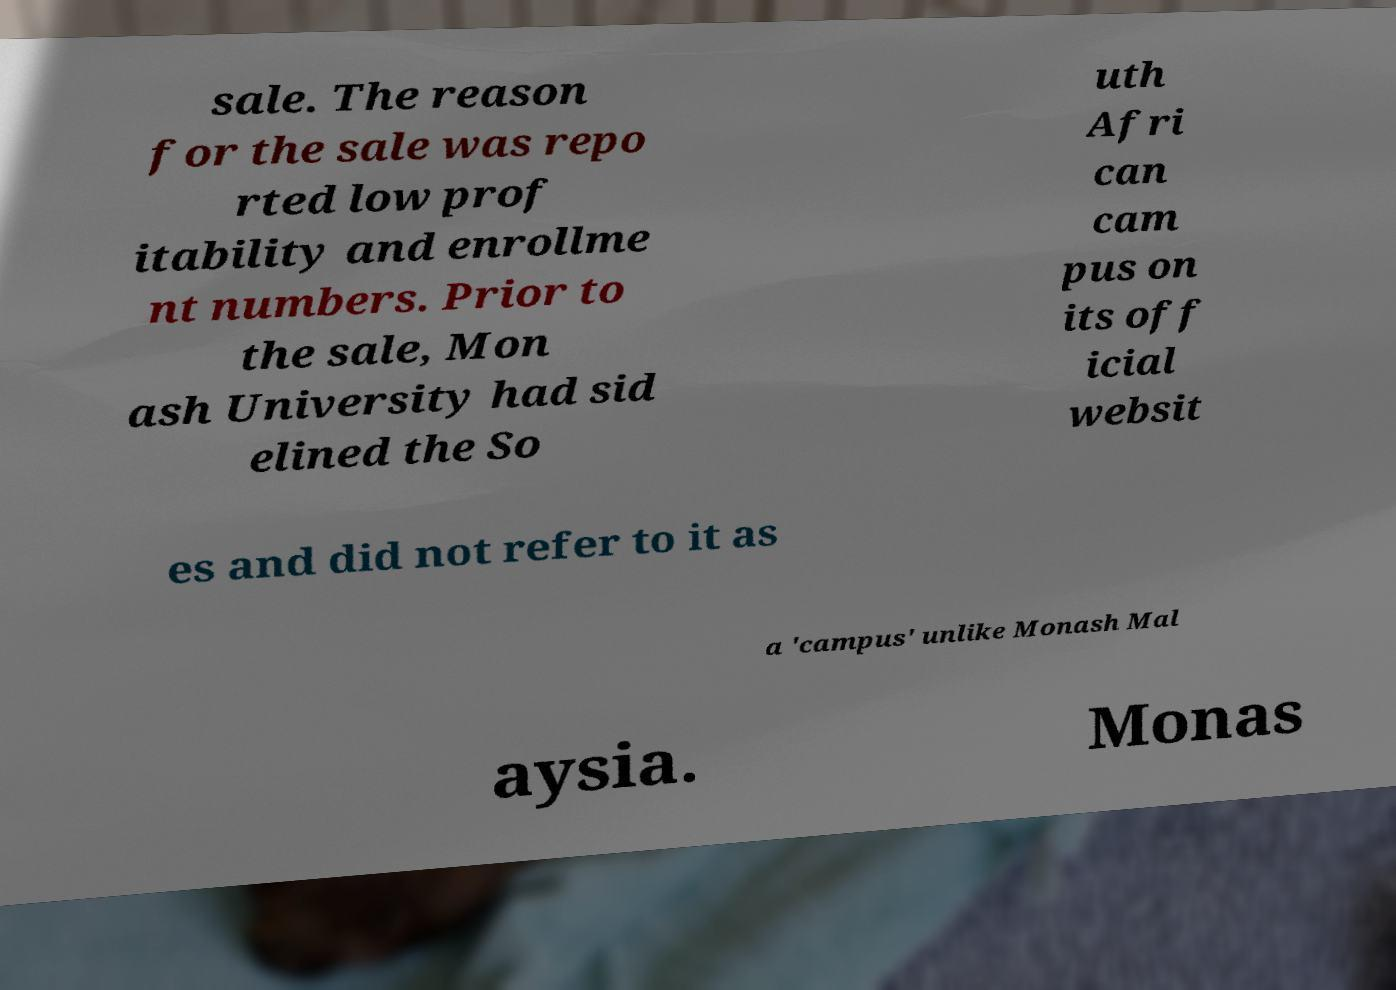Please identify and transcribe the text found in this image. sale. The reason for the sale was repo rted low prof itability and enrollme nt numbers. Prior to the sale, Mon ash University had sid elined the So uth Afri can cam pus on its off icial websit es and did not refer to it as a 'campus' unlike Monash Mal aysia. Monas 